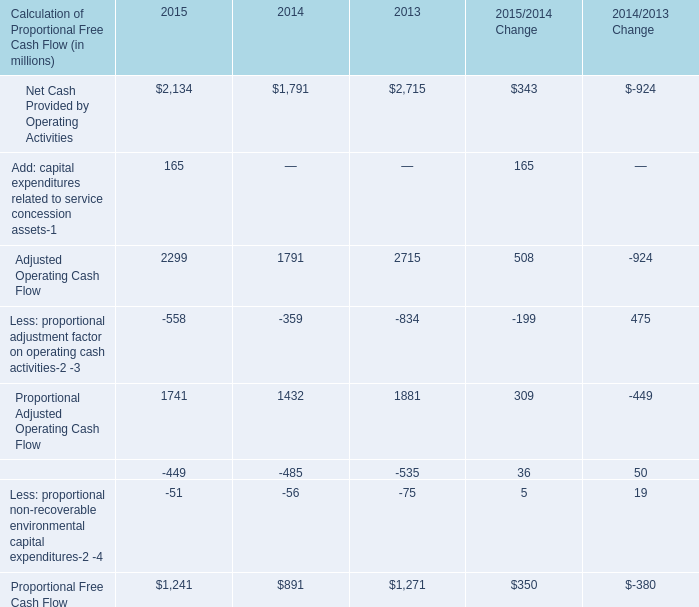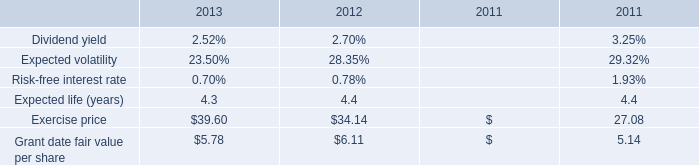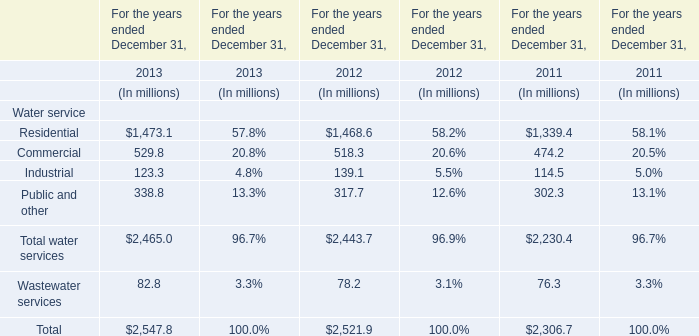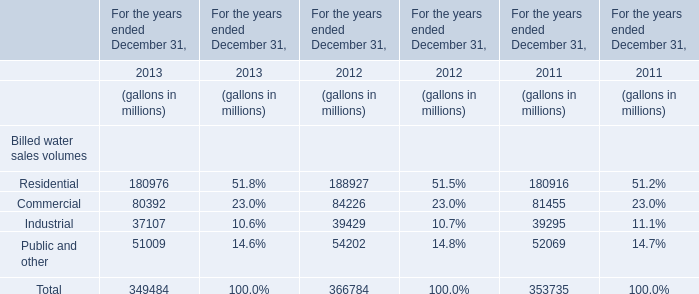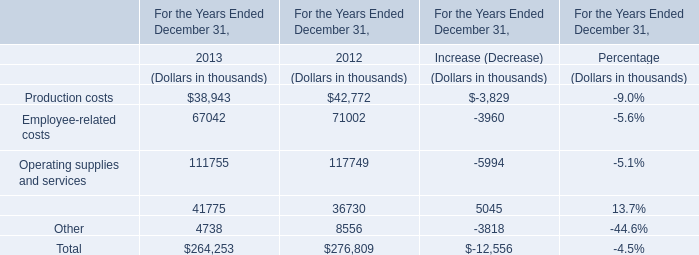What will Commercial reach in 2014 if it continues to grow at its 2013 rate? (in million) 
Computations: (80392 * (1 + ((80392 - 84226) / 84226)))
Answer: 76732.52516. 